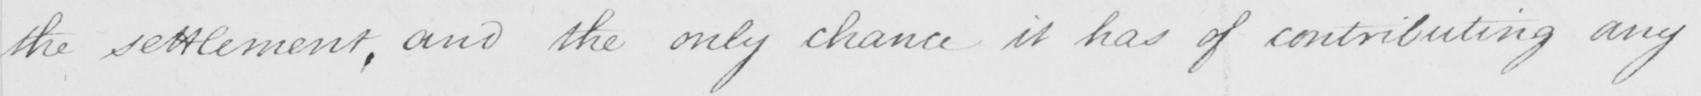What is written in this line of handwriting? the settlement , and the only chance it has of contributing any 